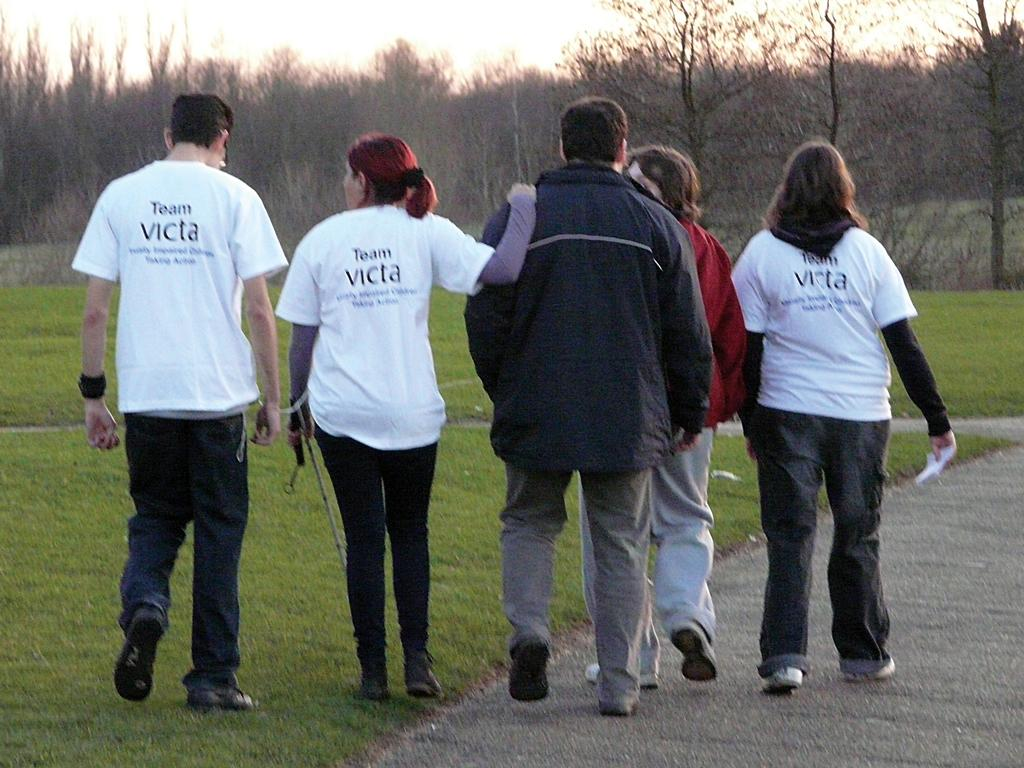How many people are in the image? There are people in the image, but the exact number is not specified. What is the person on the right side holding? The person on the right side is holding an object. What type of terrain is visible in the image? Grass is visible on the ground in the image. What type of yak can be seen wearing rings in the image? There is no yak or rings present in the image. 